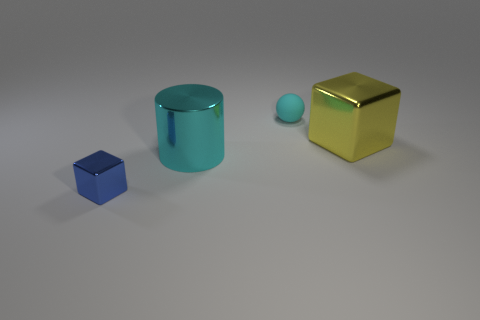Are there any other things that have the same material as the ball?
Ensure brevity in your answer.  No. The tiny rubber thing has what shape?
Provide a succinct answer. Sphere. What is the size of the rubber sphere that is the same color as the large cylinder?
Offer a very short reply. Small. How big is the metallic block in front of the metallic cube that is on the right side of the tiny cyan matte thing?
Ensure brevity in your answer.  Small. There is a block that is to the left of the matte sphere; what size is it?
Keep it short and to the point. Small. Are there fewer large cubes that are on the left side of the large yellow block than large yellow shiny objects that are behind the small blue metal thing?
Make the answer very short. Yes. What is the color of the rubber sphere?
Ensure brevity in your answer.  Cyan. Is there another big object that has the same color as the rubber object?
Your answer should be compact. Yes. There is a large shiny object that is in front of the block that is behind the block to the left of the tiny cyan rubber ball; what shape is it?
Provide a succinct answer. Cylinder. There is a block that is left of the cyan sphere; what is its material?
Offer a terse response. Metal. 